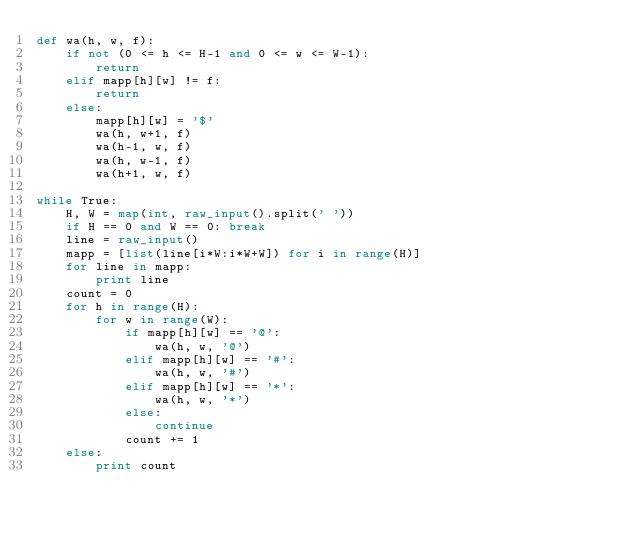Convert code to text. <code><loc_0><loc_0><loc_500><loc_500><_Python_>def wa(h, w, f):
    if not (0 <= h <= H-1 and 0 <= w <= W-1):
        return
    elif mapp[h][w] != f:
        return
    else:
        mapp[h][w] = '$'
        wa(h, w+1, f)
        wa(h-1, w, f)
        wa(h, w-1, f)
        wa(h+1, w, f)

while True:
    H, W = map(int, raw_input().split(' '))
    if H == 0 and W == 0: break
    line = raw_input()
    mapp = [list(line[i*W:i*W+W]) for i in range(H)]
    for line in mapp:
        print line
    count = 0
    for h in range(H):
        for w in range(W):
            if mapp[h][w] == '@':
                wa(h, w, '@')
            elif mapp[h][w] == '#':
                wa(h, w, '#')
            elif mapp[h][w] == '*':
                wa(h, w, '*')
            else:
                continue
            count += 1
    else:
        print count</code> 